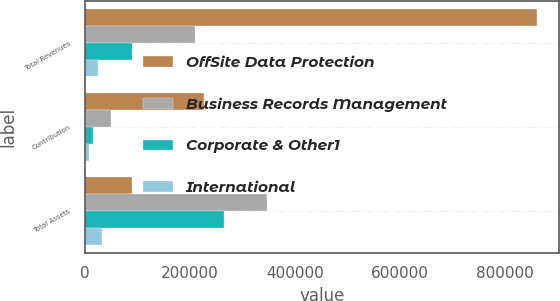Convert chart. <chart><loc_0><loc_0><loc_500><loc_500><stacked_bar_chart><ecel><fcel>Total Revenues<fcel>Contribution<fcel>Total Assets<nl><fcel>OffSite Data Protection<fcel>861302<fcel>227164<fcel>89475<nl><fcel>Business Records Management<fcel>209429<fcel>50254<fcel>348181<nl><fcel>Corporate & Other1<fcel>89475<fcel>16250<fcel>265968<nl><fcel>International<fcel>25512<fcel>7712<fcel>32079<nl></chart> 